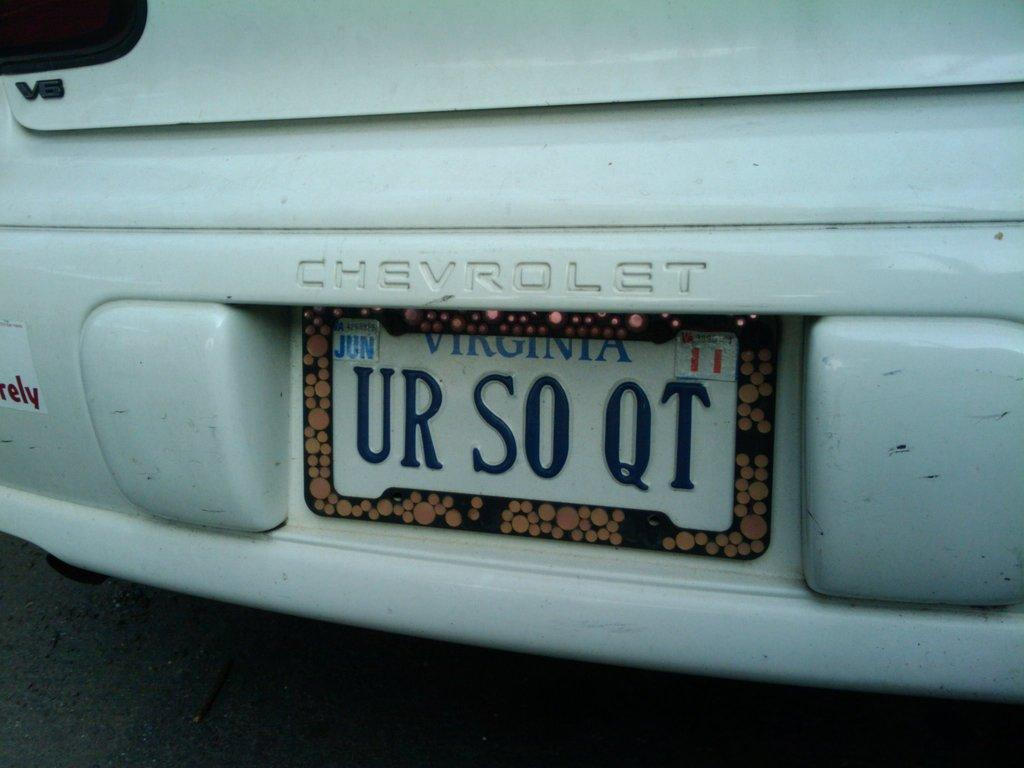<image>
Create a compact narrative representing the image presented. A white Chevrolet has a license plate that says Virginia. 